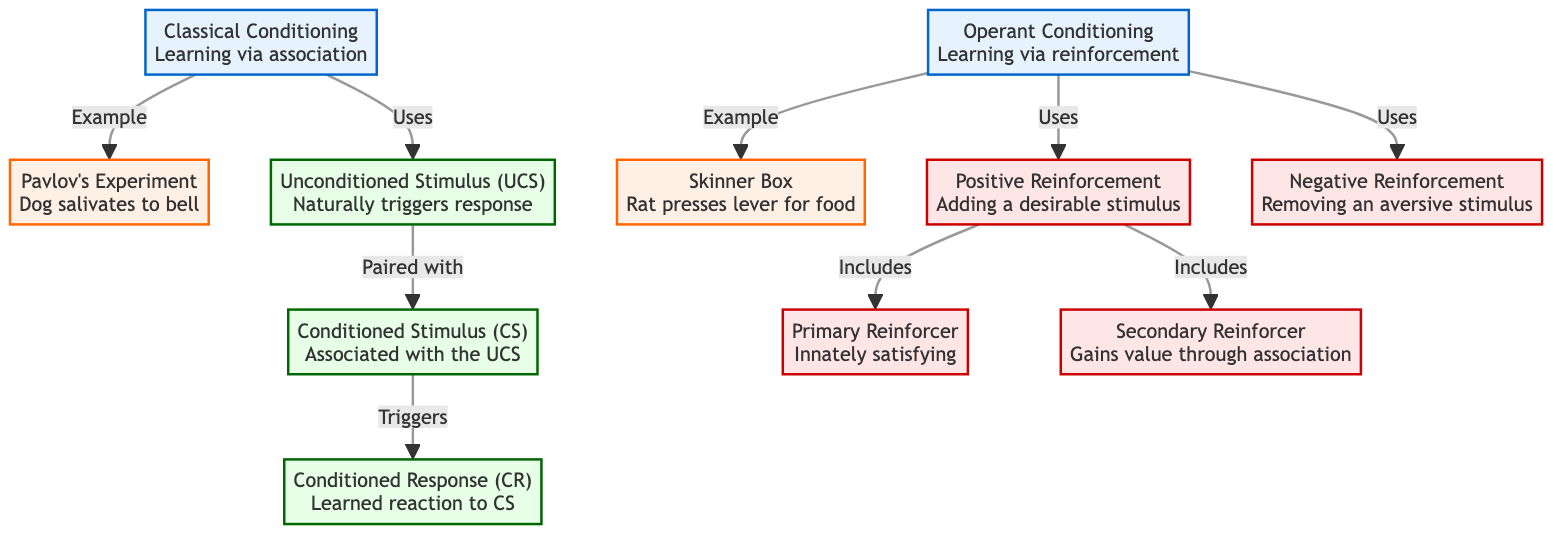What is the example of classical conditioning in the diagram? The diagram explicitly lists "Pavlov's Experiment<br>Dog salivates to bell" as the example under the classical conditioning node.
Answer: Pavlov's Experiment<br>Dog salivates to bell What does UCS stand for in the diagram? The diagram identifies "Unconditioned Stimulus (UCS)" as one of the components of classical conditioning, which naturally triggers a response.
Answer: Unconditioned Stimulus (UCS) How many types of reinforcements are mentioned under operant conditioning? The diagram lists two types of reinforcement associated with operant conditioning: positive reinforcement and negative reinforcement.
Answer: 2 What is the relationship between UCS and CS in classical conditioning? The diagram indicates that the UCS is paired with the Conditioned Stimulus (CS), which suggests a direct connection that leads to learning.
Answer: Paired with What are the two categories of reinforcers in positive reinforcement? The diagram specifies that positive reinforcement includes primary reinforcer and secondary reinforcer, detailing two distinct categories of rewards.
Answer: Primary Reinforcer, Secondary Reinforcer What example is given for operant conditioning? The diagram specifies "Skinner Box<br>Rat presses lever for food" as the example of operant conditioning, illustrating a behavior-reward scenario.
Answer: Skinner Box<br>Rat presses lever for food What type of conditioning emphasizes learning via association? The diagram specifically labels "Classical Conditioning" as the method involving learning through associating stimuli.
Answer: Classical Conditioning What type of stimulus triggers a learned reaction in the context of classical conditioning? The diagram notes that the Conditioned Response (CR) is a learned reaction triggered by the Conditioned Stimulus (CS), indicating the learning process.
Answer: Conditioned Stimulus (CS) 